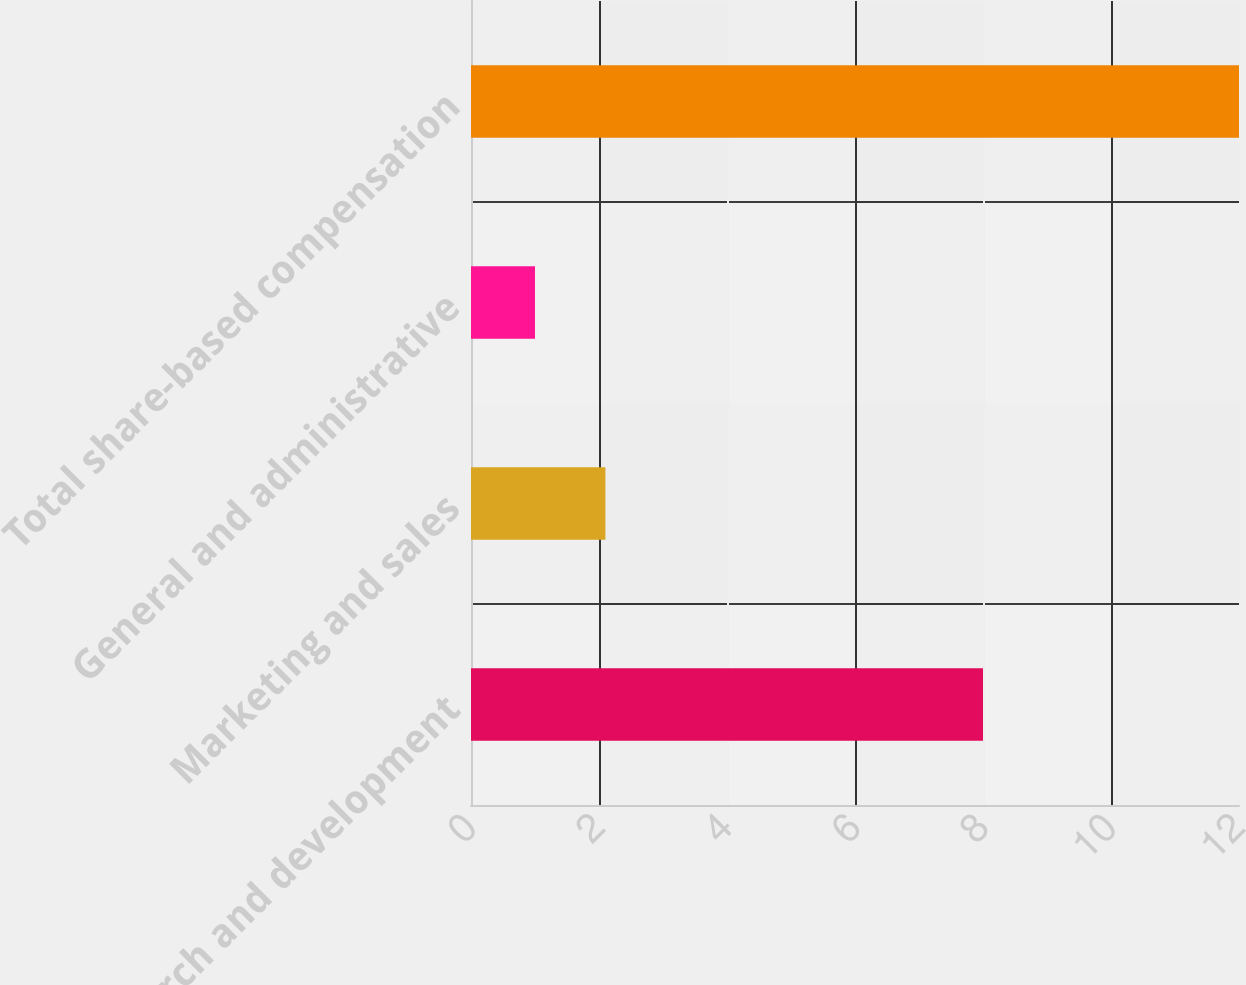<chart> <loc_0><loc_0><loc_500><loc_500><bar_chart><fcel>Research and development<fcel>Marketing and sales<fcel>General and administrative<fcel>Total share-based compensation<nl><fcel>8<fcel>2.1<fcel>1<fcel>12<nl></chart> 